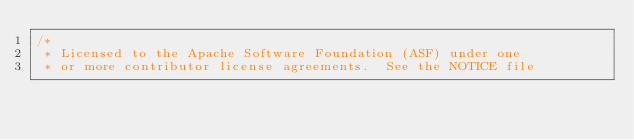<code> <loc_0><loc_0><loc_500><loc_500><_Java_>/*
 * Licensed to the Apache Software Foundation (ASF) under one
 * or more contributor license agreements.  See the NOTICE file</code> 